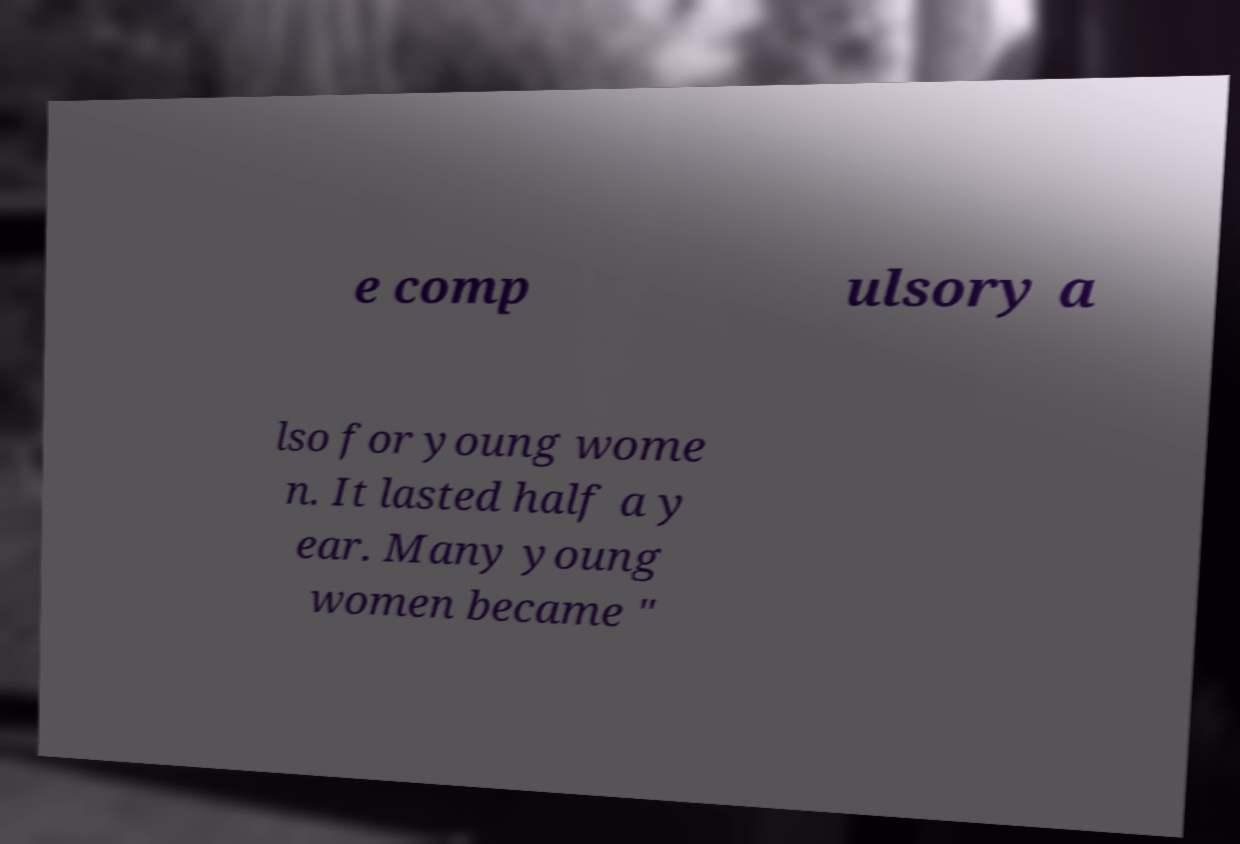Please identify and transcribe the text found in this image. e comp ulsory a lso for young wome n. It lasted half a y ear. Many young women became " 